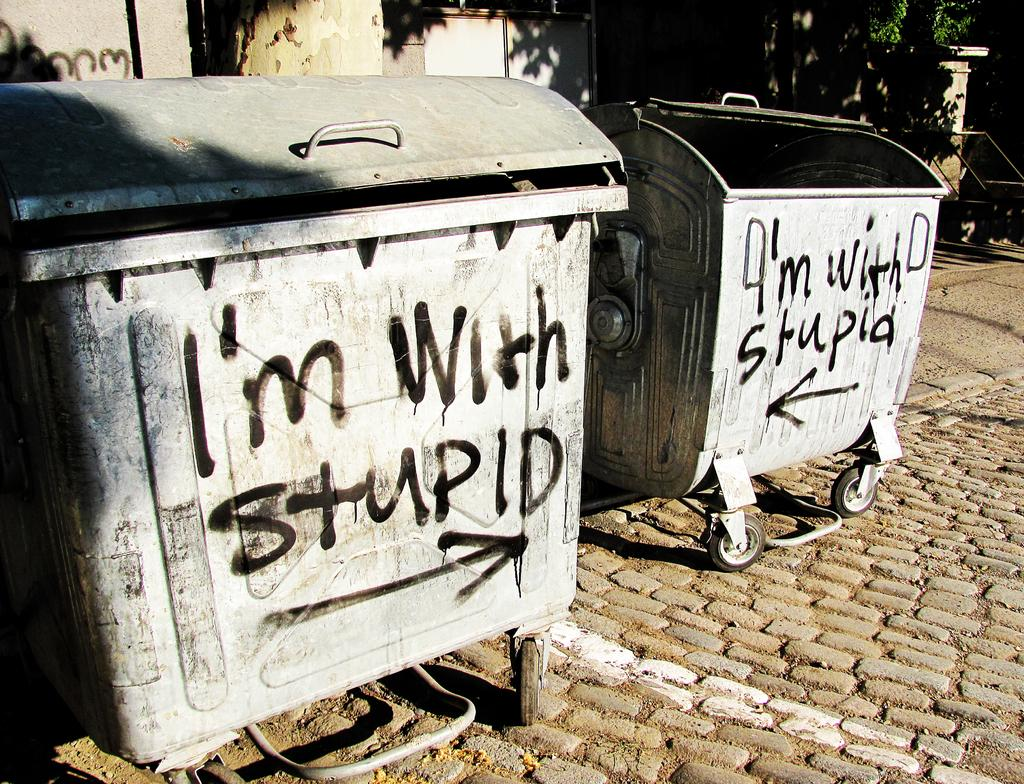<image>
Present a compact description of the photo's key features. Garbage can which says the words I'm with Stupid on it. 